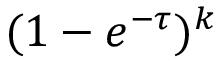<formula> <loc_0><loc_0><loc_500><loc_500>( 1 - e ^ { - \tau } ) ^ { k }</formula> 